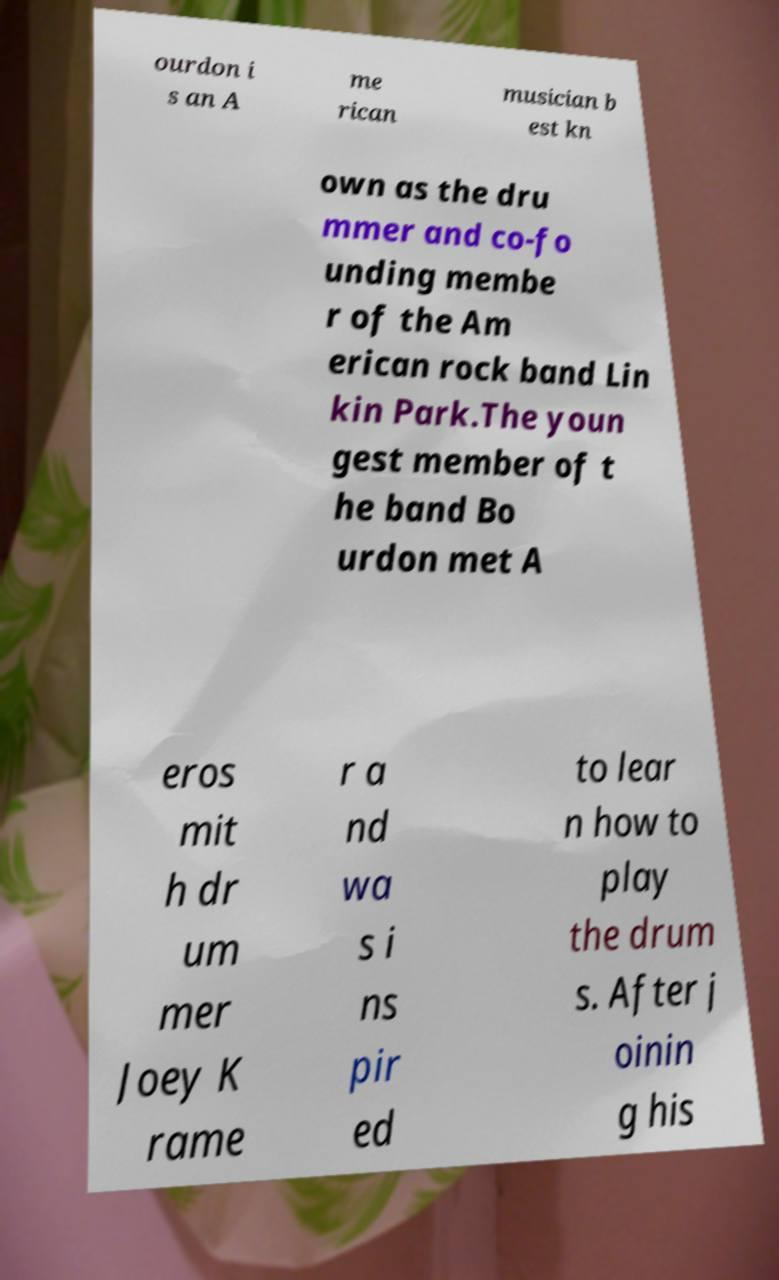There's text embedded in this image that I need extracted. Can you transcribe it verbatim? ourdon i s an A me rican musician b est kn own as the dru mmer and co-fo unding membe r of the Am erican rock band Lin kin Park.The youn gest member of t he band Bo urdon met A eros mit h dr um mer Joey K rame r a nd wa s i ns pir ed to lear n how to play the drum s. After j oinin g his 